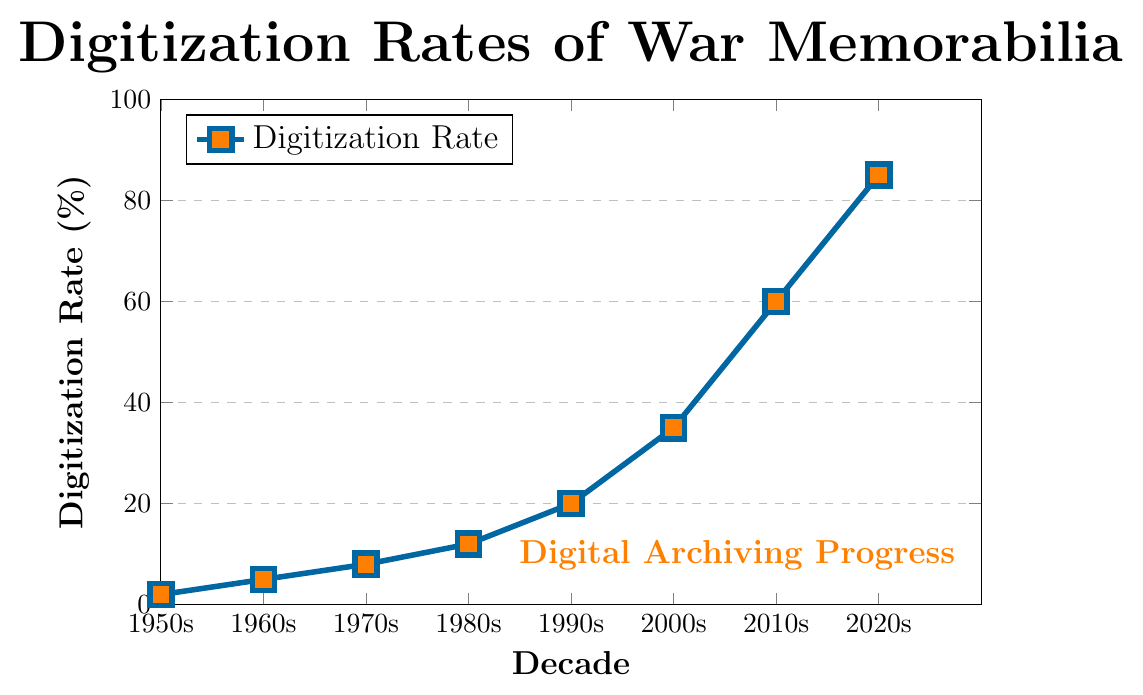What's the overall trend in digitization rates from the 1950s to the 2020s? The digitization rate is steadily increasing. Starting at 2% in the 1950s and rising to 85% by the 2020s, the chart shows a clear upward trend in preservation efforts.
Answer: Increasing How much did the digitization rate increase from the 1950s to the 2000s? The digitization rate increased from 2% in the 1950s to 35% in the 2000s. The difference is 35 - 2 = 33%.
Answer: 33% Which decade saw the highest increase in digitization rate compared to the previous decade? To find this, calculate the difference for each decade and compare: 1960s to 1950s (5%-2% = 3%), 1970s to 1960s (8%-5% = 3%), 1980s to 1970s (12%-8% = 4%), 1990s to 1980s (20%-12% = 8%), 2000s to 1990s (35%-20% = 15%), 2010s to 2000s (60%-35% = 25%), 2020s to 2010s (85%-60% = 25%). Both the 2010s to 2020s and 2000s to 2010s had the highest increase of 25%.
Answer: 2010s to 2020s, 2000s to 2010s By how much did the digitization rate increase between the 1980s and 2010s? The digitization rate increased from 12% in the 1980s to 60% in the 2010s. The difference is 60 - 12 = 48%.
Answer: 48% Identify the decade in which the digitization rate first reached at least 50%. The digitization rate first reaches 50% during the 2010s, where it climbs to 60%.
Answer: 2010s What is the average digitization rate over the entire time period shown? Sum the digitization rates: 2% + 5% + 8% + 12% + 20% + 35% + 60% + 85% = 227%, then divide by the number of decades (8). The average rate is 227 / 8 = 28.375%.
Answer: 28.375% Compare the digitization rates of the 1950s and the 1990s. Which one is higher and by how much? The digitization rate in the 1950s is 2%. In the 1990s, it is 20%. The difference is 20 - 2 = 18%, so the 1990s rate is higher by 18%.
Answer: 1990s by 18% What is the median digitization rate for the decades listed? The values in ascending order are 2%, 5%, 8%, 12%, 20%, 35%, 60%, 85%. The median is the average of the 4th and 5th values: (12 + 20) / 2 = 16%.
Answer: 16% How many decades does it take for the digitization rate to reach 20% from the 1950s? Starting from the 1950s at 2%, it reaches 20% in the 1990s. This takes (1990s - 1950s) / 10 = 4 decades.
Answer: 4 decades Describe the color and shape used to mark the data points in the plot. The data points are marked with blue squares filled with orange.
Answer: Blue squares with orange fill 